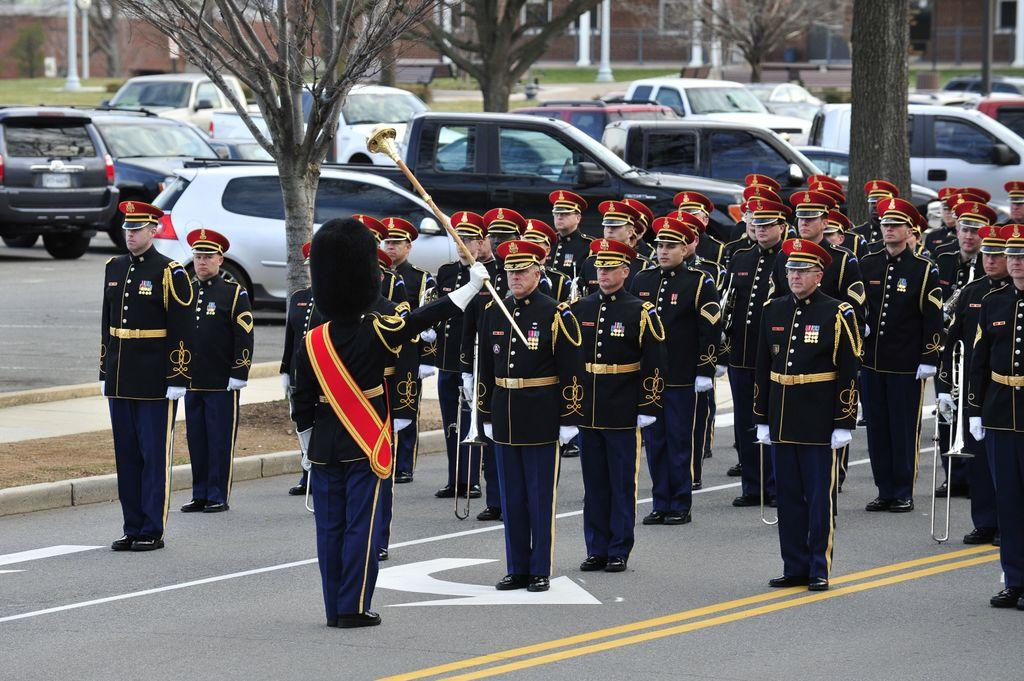What can be seen in the image involving people? There are people standing in the image. What type of vehicles are parked in the image? There are cars parked in the image. What natural elements are visible in the image? There are trees visible in the image. What type of structures can be seen in the background of the image? There are buildings in the background of the image. Are there any buns or pickles visible in the image? No, there are no buns or pickles present in the image. How many children can be seen playing in the image? There is no mention of children in the provided facts, so we cannot determine if any are present in the image. 